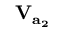Convert formula to latex. <formula><loc_0><loc_0><loc_500><loc_500>V _ { a _ { 2 } }</formula> 